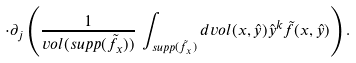<formula> <loc_0><loc_0><loc_500><loc_500>\cdot \partial _ { j } \left ( \frac { 1 } { v o l ( s u p p ( \tilde { f } _ { x } ) ) } \, \int _ { s u p p ( \tilde { f } _ { x } ) } d v o l ( x , \hat { y } ) \hat { y } ^ { k } \tilde { f } ( x , \hat { y } ) \right ) .</formula> 